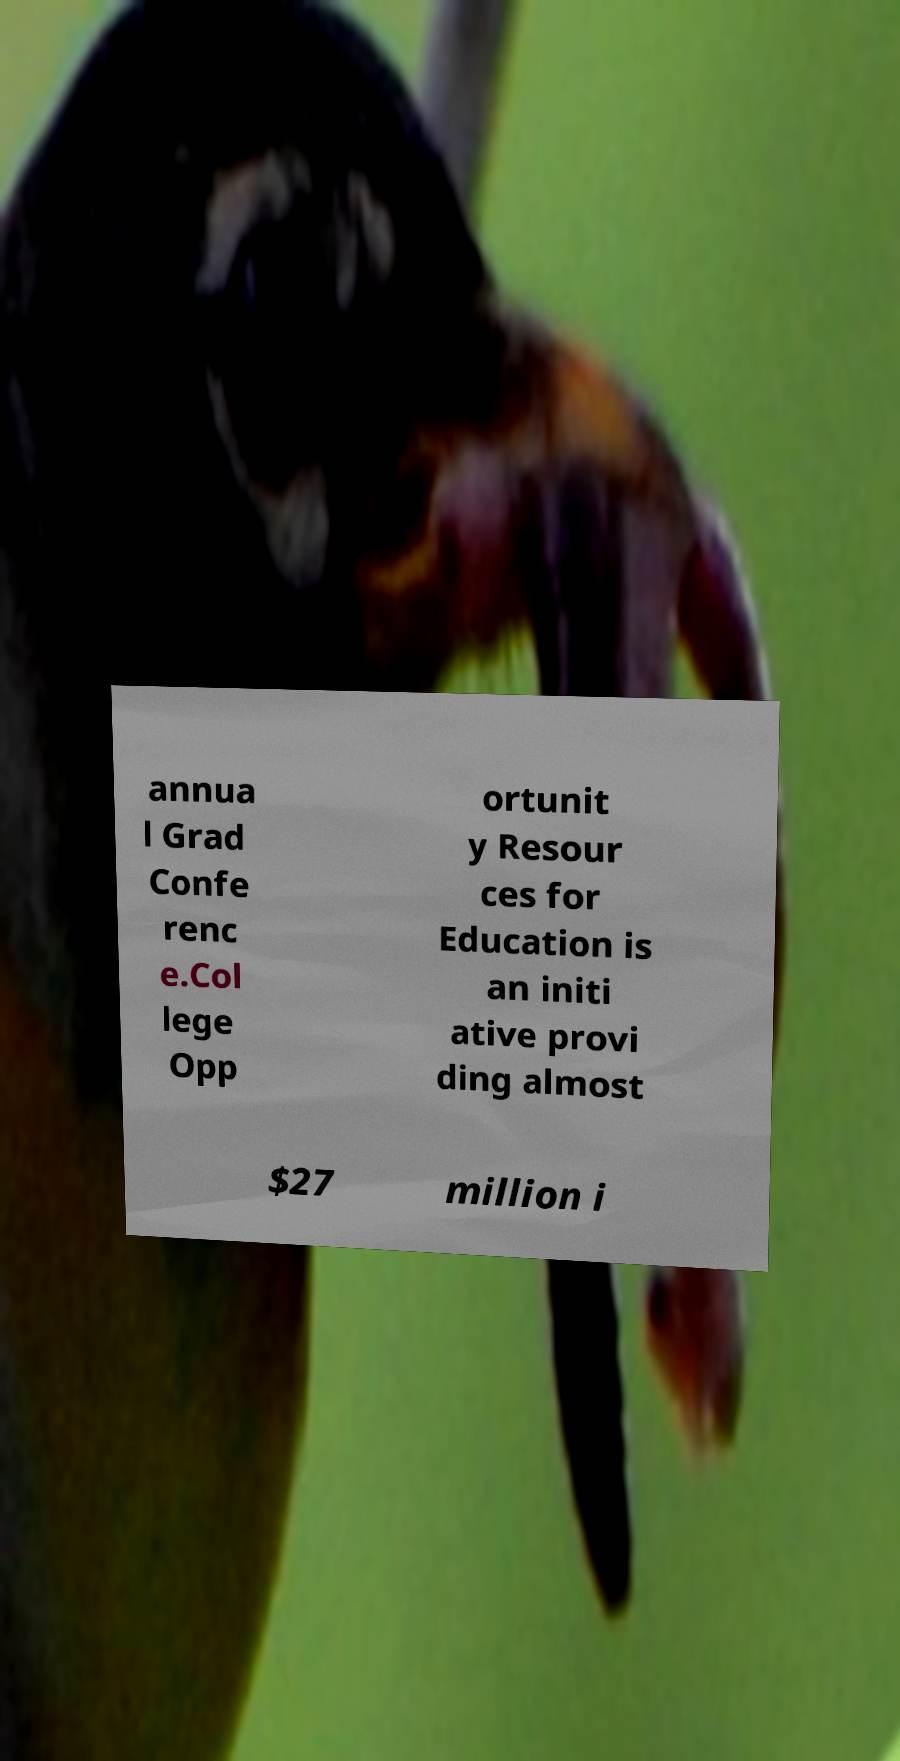For documentation purposes, I need the text within this image transcribed. Could you provide that? annua l Grad Confe renc e.Col lege Opp ortunit y Resour ces for Education is an initi ative provi ding almost $27 million i 